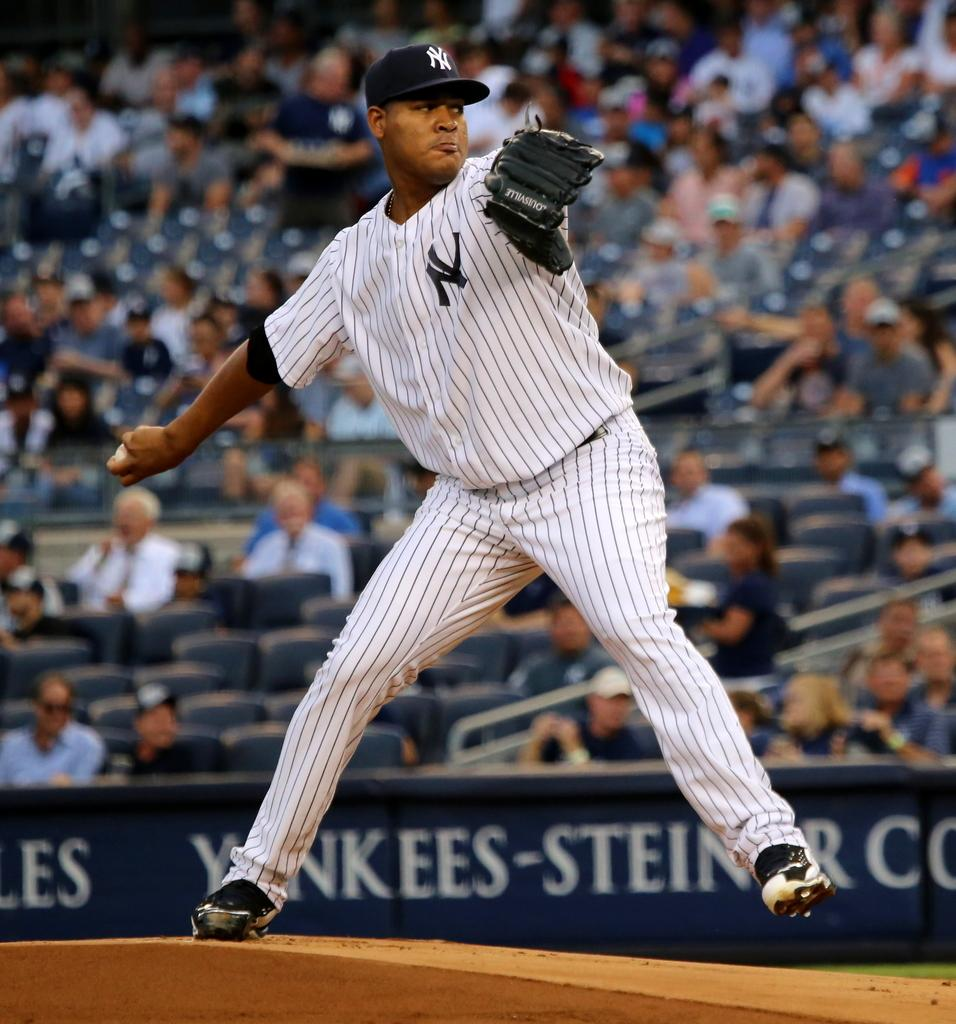<image>
Provide a brief description of the given image. A New York Yankees baseball player throwing a baseball during a game. 